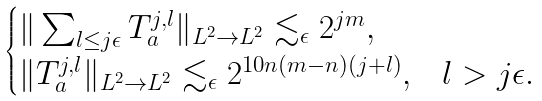<formula> <loc_0><loc_0><loc_500><loc_500>\begin{cases} \| \sum _ { l \leq j \epsilon } T _ { a } ^ { j , l } \| _ { L ^ { 2 } \to L ^ { 2 } } \lesssim _ { \epsilon } 2 ^ { j m } , \\ \| T _ { a } ^ { j , l } \| _ { L ^ { 2 } \to L ^ { 2 } } \lesssim _ { \epsilon } 2 ^ { 1 0 n ( m - n ) ( j + l ) } , & l > j \epsilon . \end{cases}</formula> 